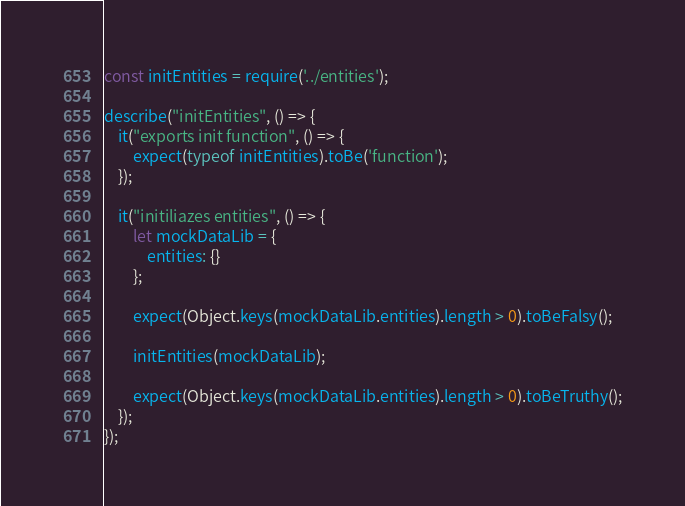Convert code to text. <code><loc_0><loc_0><loc_500><loc_500><_JavaScript_>const initEntities = require('../entities');

describe("initEntities", () => {
    it("exports init function", () => {
        expect(typeof initEntities).toBe('function');
    });

    it("initiliazes entities", () => {
        let mockDataLib = {
            entities: {}
        };

        expect(Object.keys(mockDataLib.entities).length > 0).toBeFalsy();

        initEntities(mockDataLib);

        expect(Object.keys(mockDataLib.entities).length > 0).toBeTruthy();
    });
});</code> 